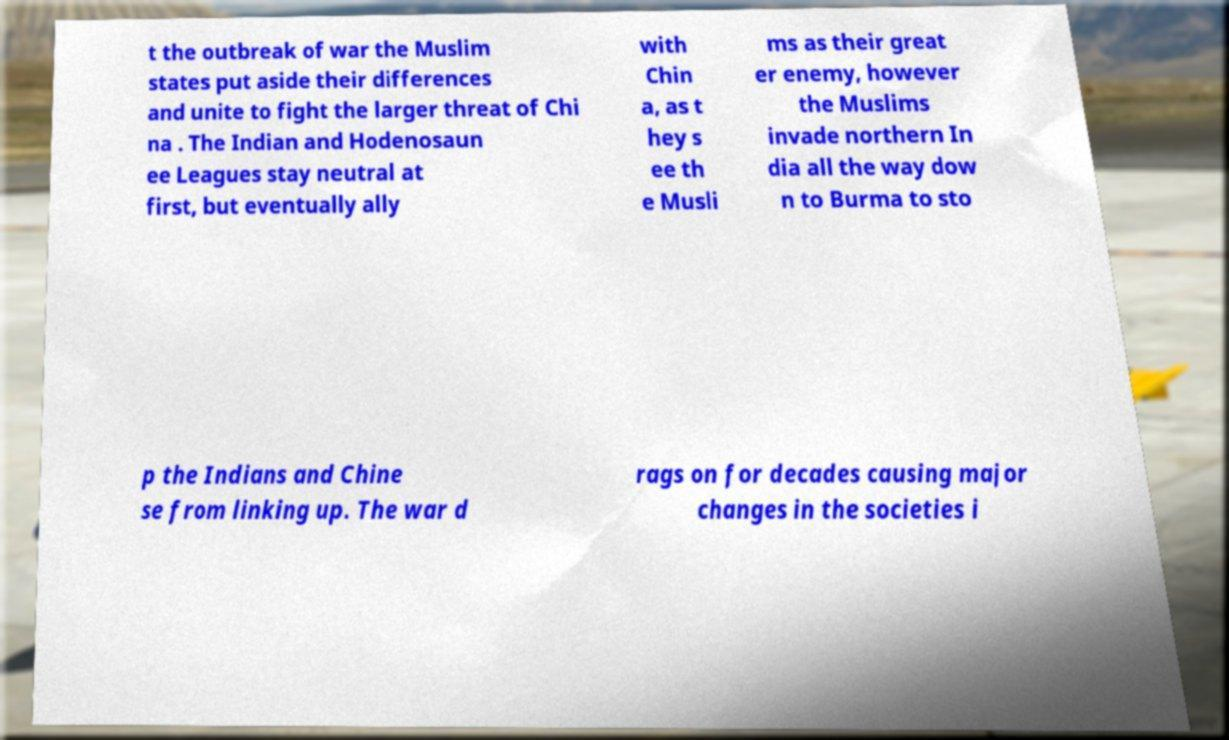Please identify and transcribe the text found in this image. t the outbreak of war the Muslim states put aside their differences and unite to fight the larger threat of Chi na . The Indian and Hodenosaun ee Leagues stay neutral at first, but eventually ally with Chin a, as t hey s ee th e Musli ms as their great er enemy, however the Muslims invade northern In dia all the way dow n to Burma to sto p the Indians and Chine se from linking up. The war d rags on for decades causing major changes in the societies i 